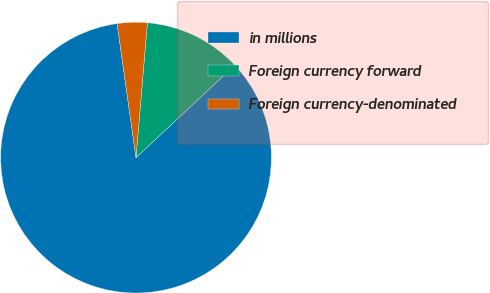<chart> <loc_0><loc_0><loc_500><loc_500><pie_chart><fcel>in millions<fcel>Foreign currency forward<fcel>Foreign currency-denominated<nl><fcel>84.74%<fcel>11.69%<fcel>3.57%<nl></chart> 